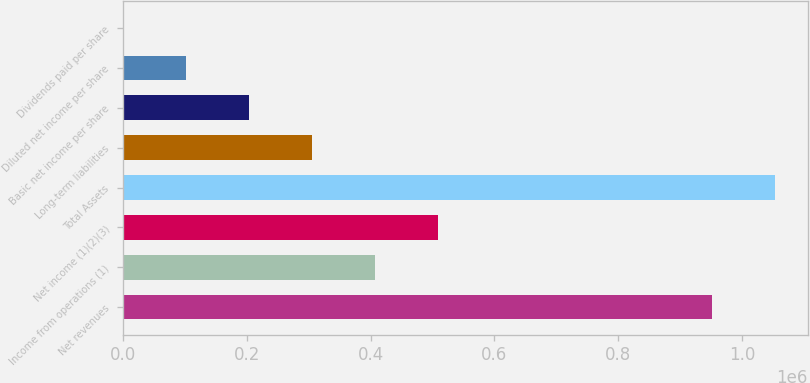Convert chart. <chart><loc_0><loc_0><loc_500><loc_500><bar_chart><fcel>Net revenues<fcel>Income from operations (1)<fcel>Net income (1)(2)(3)<fcel>Total Assets<fcel>Long-term liabilities<fcel>Basic net income per share<fcel>Diluted net income per share<fcel>Dividends paid per share<nl><fcel>951643<fcel>406864<fcel>508580<fcel>1.05336e+06<fcel>305148<fcel>203432<fcel>101716<fcel>0.12<nl></chart> 